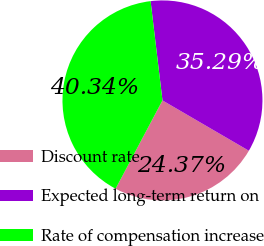Convert chart. <chart><loc_0><loc_0><loc_500><loc_500><pie_chart><fcel>Discount rate<fcel>Expected long-term return on<fcel>Rate of compensation increase<nl><fcel>24.37%<fcel>35.29%<fcel>40.34%<nl></chart> 